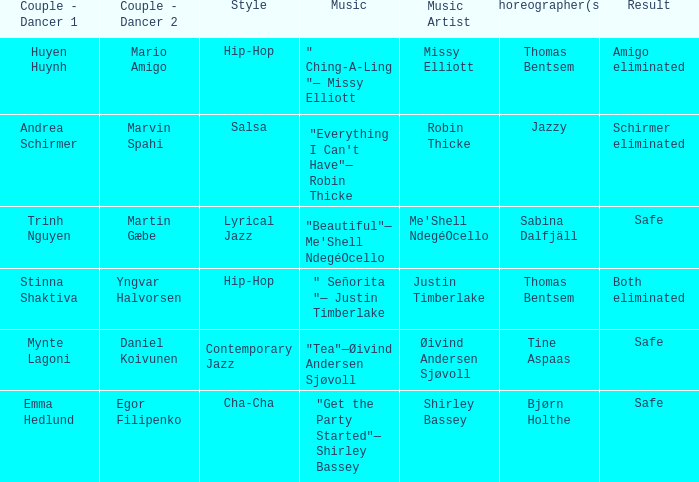What is the result of choreographer bjørn holthe? Safe. Write the full table. {'header': ['Couple - Dancer 1', 'Couple - Dancer 2', 'Style', 'Music', 'Music Artist', 'Choreographer(s)', 'Result'], 'rows': [['Huyen Huynh', 'Mario Amigo', 'Hip-Hop', '" Ching-A-Ling "— Missy Elliott', 'Missy Elliott', 'Thomas Bentsem', 'Amigo eliminated'], ['Andrea Schirmer', 'Marvin Spahi', 'Salsa', '"Everything I Can\'t Have"— Robin Thicke', 'Robin Thicke', 'Jazzy', 'Schirmer eliminated'], ['Trinh Nguyen', 'Martin Gæbe', 'Lyrical Jazz', '"Beautiful"— Me\'Shell NdegéOcello', "Me'Shell NdegéOcello", 'Sabina Dalfjäll', 'Safe'], ['Stinna Shaktiva', 'Yngvar Halvorsen', 'Hip-Hop', '" Señorita "— Justin Timberlake', 'Justin Timberlake', 'Thomas Bentsem', 'Both eliminated'], ['Mynte Lagoni', 'Daniel Koivunen', 'Contemporary Jazz', '"Tea"—Øivind Andersen Sjøvoll', 'Øivind Andersen Sjøvoll', 'Tine Aspaas', 'Safe'], ['Emma Hedlund', 'Egor Filipenko', 'Cha-Cha', '"Get the Party Started"— Shirley Bassey', 'Shirley Bassey', 'Bjørn Holthe', 'Safe']]} 